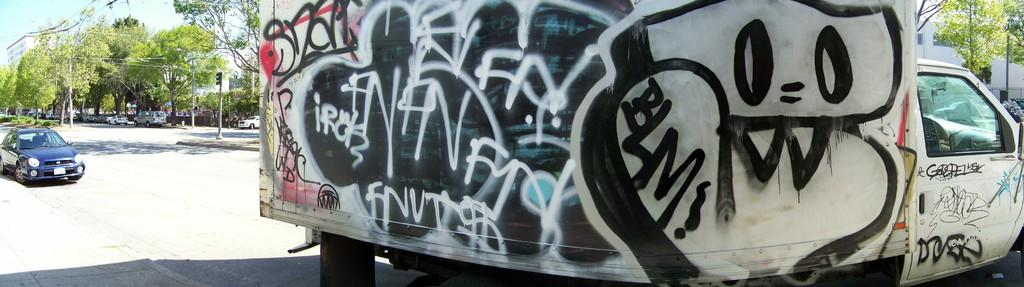What types of objects can be seen in the image? There are vehicles, poles, and buildings in the image. What is the purpose of the poles in the image? The purpose of the poles is not explicitly stated, but they may be used for streetlights, signs, or other infrastructure. What is the surface on which the vehicles are traveling? There is a road in the image on which the vehicles are traveling. What can be seen in the background of the image? The sky is visible in the image. Can you tell me how many balloons are tied to the poles in the image? There are no balloons present in the image; it features vehicles, poles, and buildings. What type of slope can be seen in the image? There is no slope present in the image; it features a road and vehicles. 